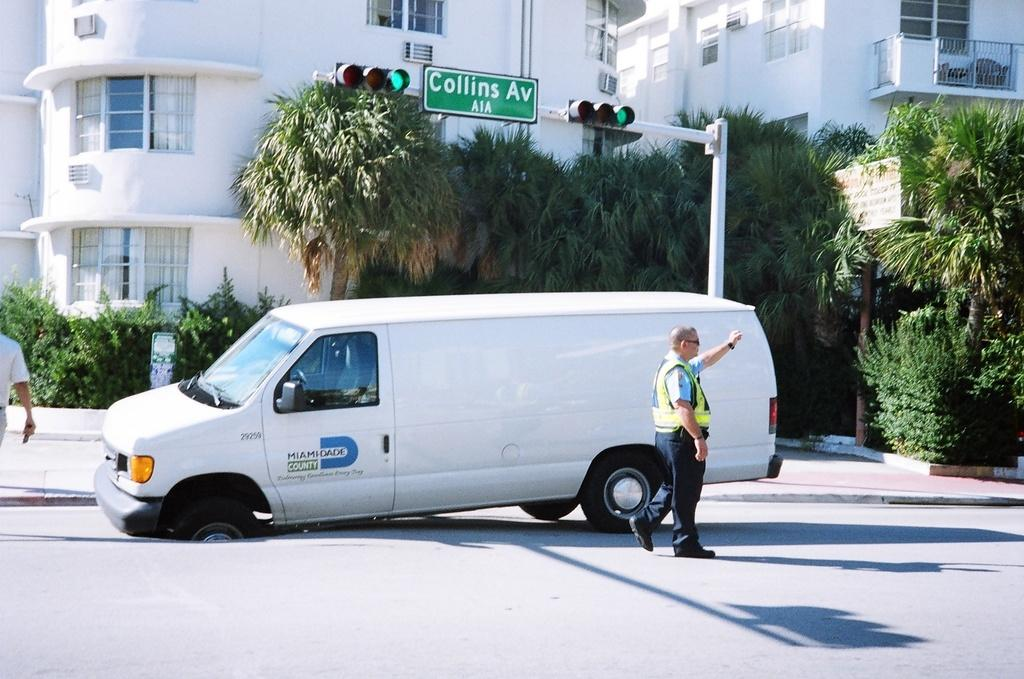<image>
Relay a brief, clear account of the picture shown. a van with the word county on it that is outside in daytime 